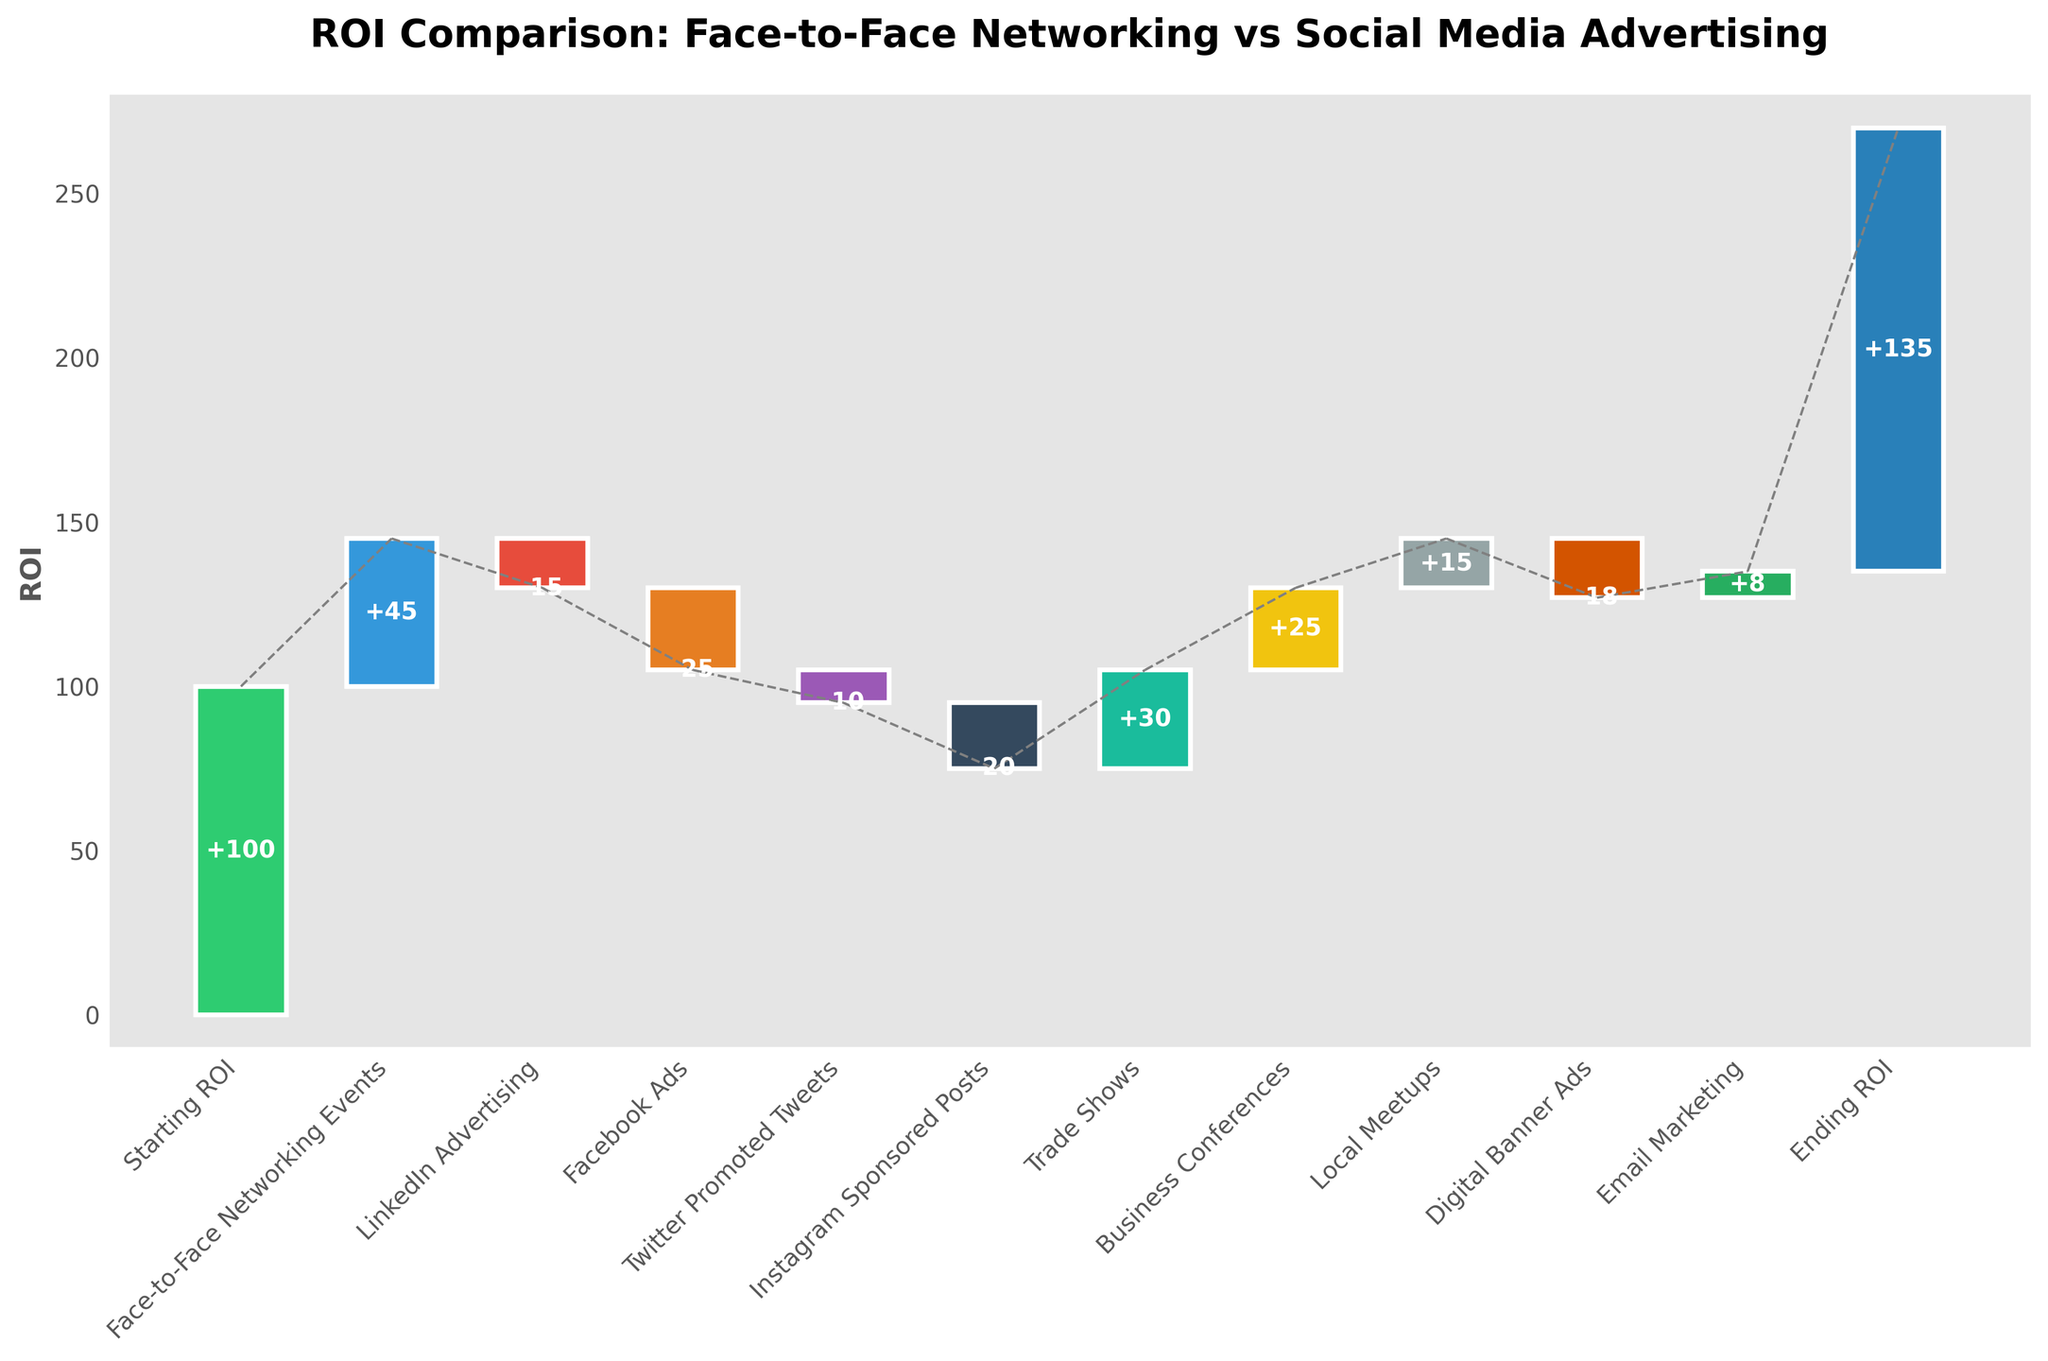How many data points are in the figure? Count the number of bars in the figure. Each bar corresponds to a data point. There are 12 bars shown.
Answer: 12 What is the title of the chart? Read the title displayed at the top of the chart. It states: "ROI Comparison: Face-to-Face Networking vs Social Media Advertising".
Answer: ROI Comparison: Face-to-Face Networking vs Social Media Advertising Which category has the highest positive value? Look for the bar with the highest positive value. By comparing the heights of the positive bars, the "Business Conferences" category has the highest value of +25.
Answer: Business Conferences What is the ending ROI? Refer to the last data point in the waterfall chart. The ending ROI is indicated by the final cumulative value. It is 135.
Answer: 135 Which social media platform had the most negative impact on ROI? Examine the bars corresponding to social media platforms: LinkedIn Advertising, Facebook Ads, Twitter Promoted Tweets, and Instagram Sponsored Posts. Facebook Ads has the most negative impact with a value of -25.
Answer: Facebook Ads What is the cumulative ROI before considering Email Marketing? To find this, sum all the values up to and including "Digital Banner Ads". Starting ROI = 100, add Face-to-Face Networking Events (45), LinkedIn Advertising (-15), Facebook Ads (-25), Twitter Promoted Tweets (-10), Instagram Sponsored Posts (-20), Trade Shows (30), Business Conferences (25), Local Meetups (15), Digital Banner Ads (-18). The sum is: 100 + 45 - 15 - 25 - 10 - 20 + 30 + 25 + 15 - 18 = 127.
Answer: 127 Name one category with a positive impact on ROI. Check the bars where values are positive. Examples include: Face-to-Face Networking Events, Trade Shows, Business Conferences, Local Meetups, and Email Marketing. Any of these can be an answer, e.g., Trade Shows.
Answer: Trade Shows Which category resulted in a decrease of 10 units in ROI? Identify the category with a bar value of -10. "Twitter Promoted Tweets" shows a decrease of -10.
Answer: Twitter Promoted Tweets What is the difference in value between LinkedIn Advertising and Face-to-Face Networking Events? Subtract the value of LinkedIn Advertising from the value of Face-to-Face Networking Events. 45 - (-15) = 45 + 15 = 60.
Answer: 60 Which networking event had a higher ROI: Trade Shows or Local Meetups? Compare the values associated with Trade Shows and Local Meetups. Trade Shows had an ROI of 30, whereas Local Meetups had an ROI of 15. Therefore, Trade Shows had a higher ROI.
Answer: Trade Shows 